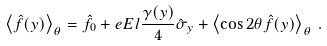Convert formula to latex. <formula><loc_0><loc_0><loc_500><loc_500>\left \langle \hat { f } ( y ) \right \rangle _ { \theta } = \hat { f } _ { 0 } + e E l \frac { \gamma ( y ) } { 4 } \hat { \sigma } _ { y } + \left \langle \cos 2 \theta \hat { f } ( y ) \right \rangle _ { \theta } \, .</formula> 